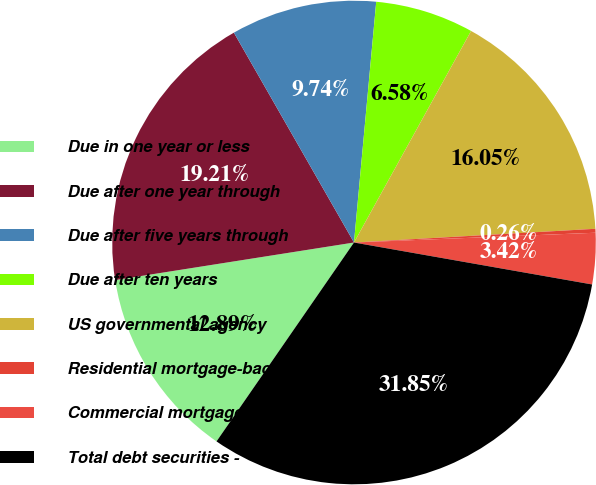Convert chart to OTSL. <chart><loc_0><loc_0><loc_500><loc_500><pie_chart><fcel>Due in one year or less<fcel>Due after one year through<fcel>Due after five years through<fcel>Due after ten years<fcel>US governmental agency<fcel>Residential mortgage-backed<fcel>Commercial mortgage-backed<fcel>Total debt securities -<nl><fcel>12.89%<fcel>19.21%<fcel>9.74%<fcel>6.58%<fcel>16.05%<fcel>0.26%<fcel>3.42%<fcel>31.85%<nl></chart> 